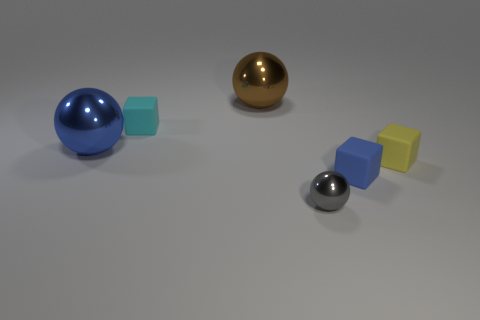There is a thing that is on the right side of the tiny blue rubber thing; what shape is it?
Provide a short and direct response. Cube. What number of yellow objects have the same size as the gray thing?
Your answer should be compact. 1. Is the color of the matte object to the left of the tiny gray thing the same as the tiny metallic thing?
Your answer should be very brief. No. There is a small object that is in front of the yellow matte object and on the left side of the blue matte object; what material is it?
Provide a succinct answer. Metal. Are there more gray rubber blocks than cyan rubber things?
Give a very brief answer. No. What is the color of the object behind the small cube that is to the left of the small sphere that is in front of the large blue shiny ball?
Your answer should be very brief. Brown. Do the big ball that is in front of the cyan cube and the small cyan block have the same material?
Make the answer very short. No. Are there any big shiny cubes that have the same color as the small metallic sphere?
Offer a terse response. No. Is there a large thing?
Your answer should be compact. Yes. There is a sphere left of the cyan cube; is its size the same as the large brown metal sphere?
Make the answer very short. Yes. 